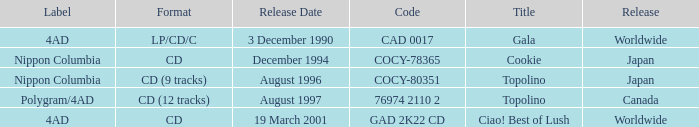Could you help me parse every detail presented in this table? {'header': ['Label', 'Format', 'Release Date', 'Code', 'Title', 'Release'], 'rows': [['4AD', 'LP/CD/C', '3 December 1990', 'CAD 0017', 'Gala', 'Worldwide'], ['Nippon Columbia', 'CD', 'December 1994', 'COCY-78365', 'Cookie', 'Japan'], ['Nippon Columbia', 'CD (9 tracks)', 'August 1996', 'COCY-80351', 'Topolino', 'Japan'], ['Polygram/4AD', 'CD (12 tracks)', 'August 1997', '76974 2110 2', 'Topolino', 'Canada'], ['4AD', 'CD', '19 March 2001', 'GAD 2K22 CD', 'Ciao! Best of Lush', 'Worldwide']]} What Label has a Code of cocy-78365? Nippon Columbia. 